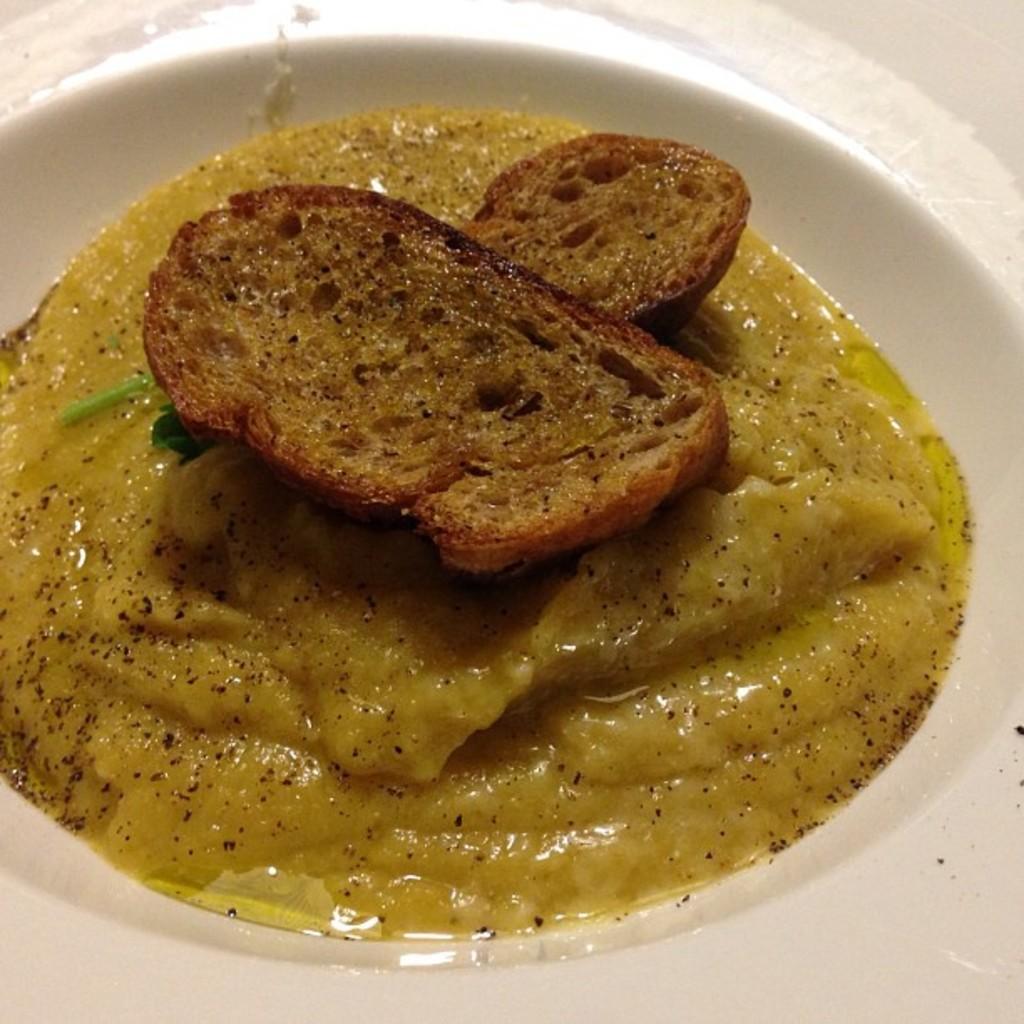Could you give a brief overview of what you see in this image? These are the food items in a white color plate. 